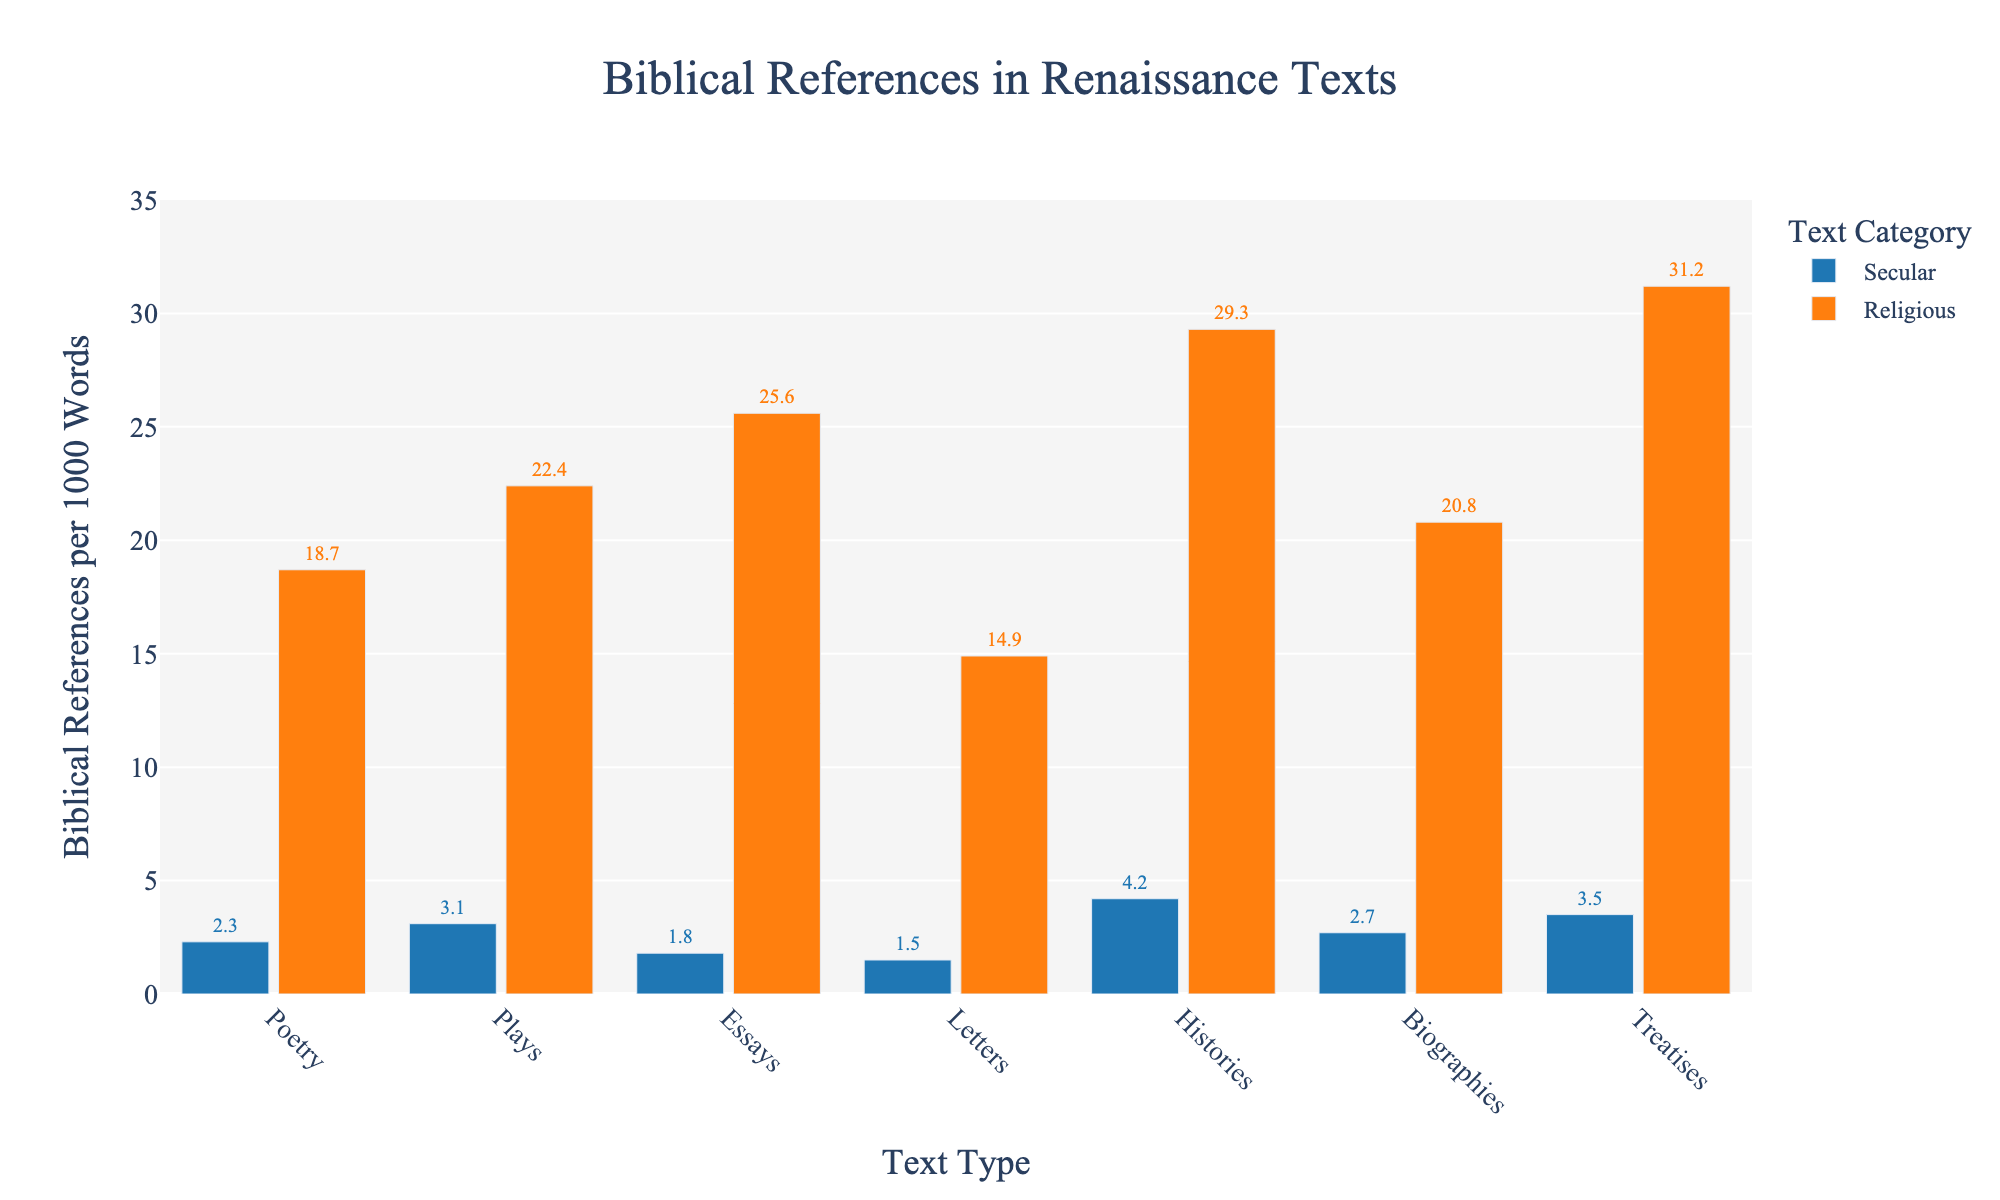What is the difference in biblical references per 1000 words between religious and secular plays? The bar for religious plays shows 22.4 biblical references per 1000 words, while the bar for secular plays shows 3.1. Subtracting 3.1 from 22.4, we get 19.3.
Answer: 19.3 Which type of religious text has the highest number of biblical references per 1000 words? Among the religious texts, the height of the bar for religious treatises is the greatest, showing 31.2 biblical references per 1000 words.
Answer: Religious treatises How many more biblical references per 1000 words are there in religious biographies compared to secular biographies? The bar for religious biographies indicates 20.8 references, while the bar for secular biographies shows 2.7. Subtracting 2.7 from 20.8, we get 18.1.
Answer: 18.1 What is the combined value of biblical references per 1000 words for secular and religious essays? The bar for secular essays shows 1.8 references, and the bar for religious essays shows 25.6. Adding these together gives 1.8 + 25.6 = 27.4.
Answer: 27.4 Do religious letters or religious poetry have more biblical references per 1000 words? By comparing the heights of the bars, we see that the bar for religious poetry is taller than that for religious letters, with values of 18.7 and 14.9 respectively.
Answer: Religious poetry Are secular letters or secular essays more likely to contain biblical references? The height of the bar for secular essays (1.8) is slightly higher than that for secular letters (1.5).
Answer: Secular essays What is the average number of biblical references per 1000 words in all religious text types? Summing up the biblical references per 1000 words for all religious text types (18.7 + 22.4 + 25.6 + 14.9 + 29.3 + 20.8 + 31.2) = 162.9. There are 7 types, so the average is 162.9 / 7 = 23.27.
Answer: 23.27 Which secular text type has the fewest biblical references per 1000 words? Among the secular text bars, the lowest bar is for secular letters, which has 1.5 references per 1000 words.
Answer: Secular letters Are there more biblical references in secular histories or secular biographies? The bar for secular histories shows 4.2 biblical references per 1000 words, whereas the bar for secular biographies shows 2.7.
Answer: Secular histories 